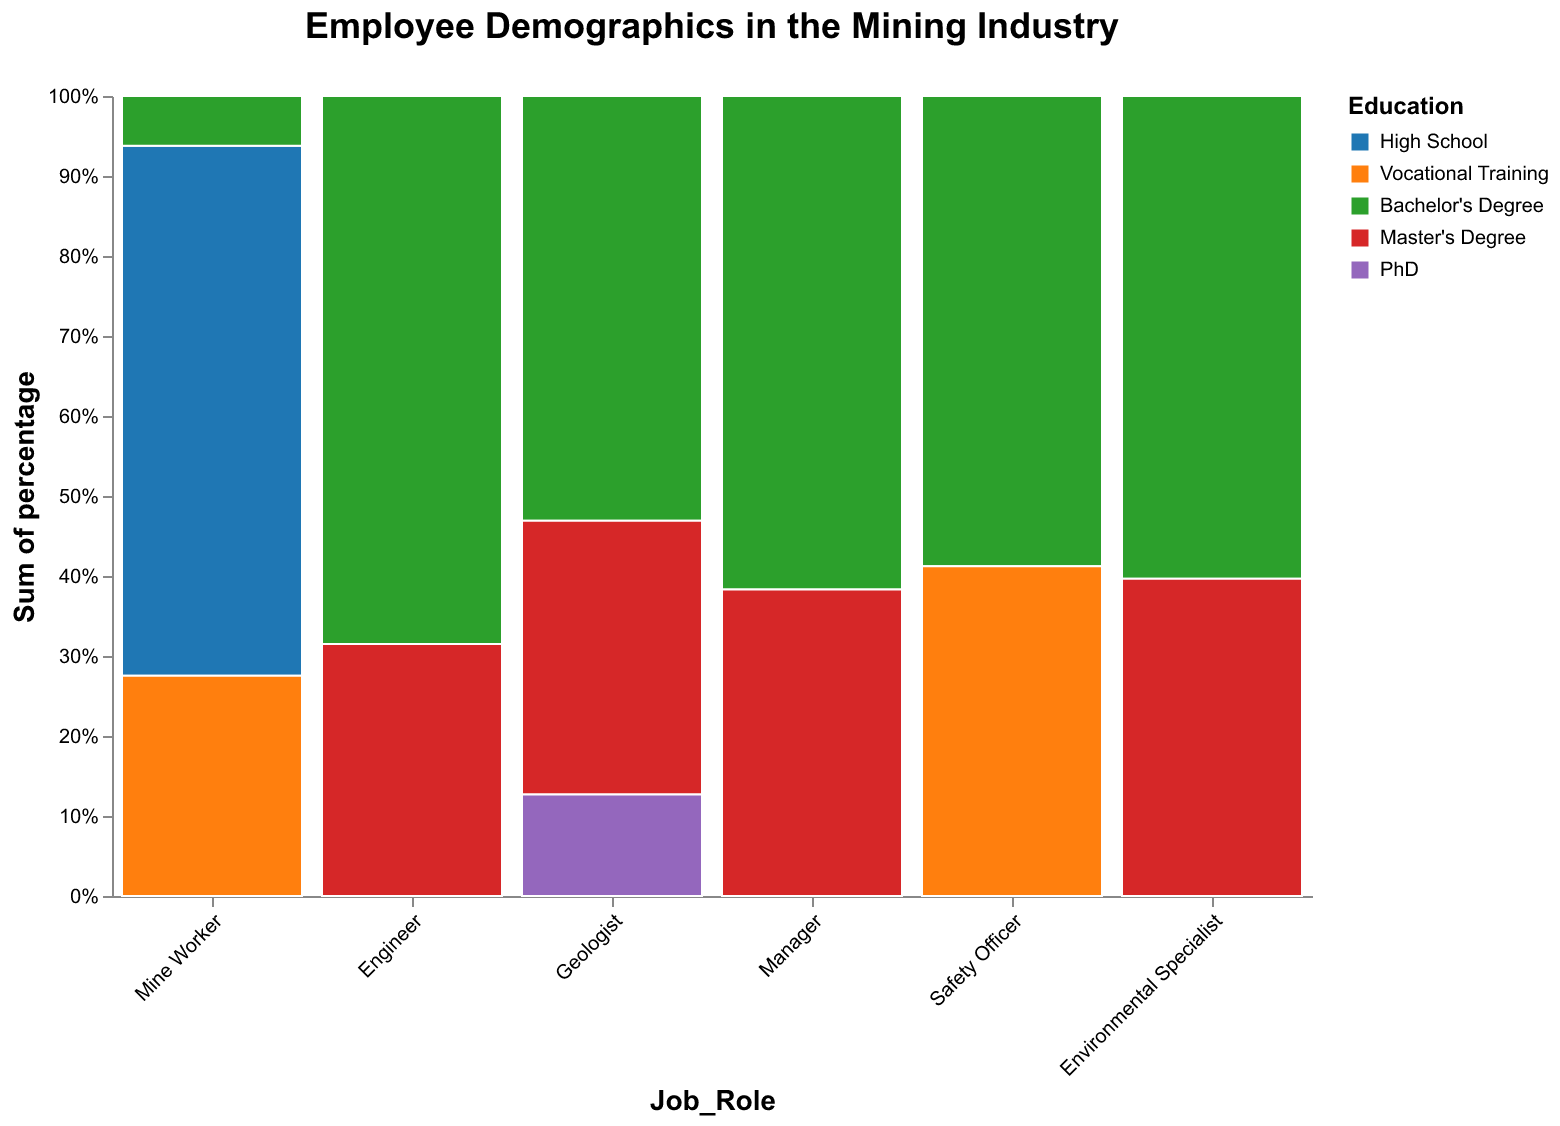what's the title of the figure? The title is prominently displayed at the top of the figure, reading "Employee Demographics in the Mining Industry".
Answer: Employee Demographics in the Mining Industry How many categories of job roles are shown in the figure? The x-axis lists different job roles. By counting these, we can see there are various job roles displayed.
Answer: Six In which job role does the bachelor's degree appear most frequently? Each bar is broken down into segments by education level. The widest green segment (Bachelor's Degree) corresponds to Mine Workers.
Answer: Mine Workers What's the percentage of engineers with a master's degree? By hovering over the master's degree portion of the engineer's bar, the tooltip displays the percentage.
Answer: 33.3% Which job role has a PhD segment? The PhD segment is a distinct color (purple) and only appears in the Geologist job role.
Answer: Geologist Is there any job role where the High School education level doesn't appear? By examining each job role, we see that High School education isn't represented in roles like Engineer, Geologist, Manager, Safety Officer, and Environmental Specialist.
Answer: Yes What's the total percentage of Mine Workers with high school or vocational training education? Add the percentage of Mine Workers with high school education to the percentage with vocational training.
Answer: 72.5% How many job roles have a majority of employees with a bachelor's degree? Observing the normalized stacked bar, count the roles where the Bachelor's Degree segment is more than 50%. Only the Engineer role has a majority (60%) Bachelor's Degree.
Answer: One Compare the number of Safety Officers with Bachelor's Degree to Environmental Specialists with same education. Both segments of Bachelor's Degree (green) should be compared visually.
Answer: Safety Officers have more Which job role shows the most diversity in educational background? Examine which job role has the most different colored segments indicating various educational backgrounds.
Answer: Geologist 